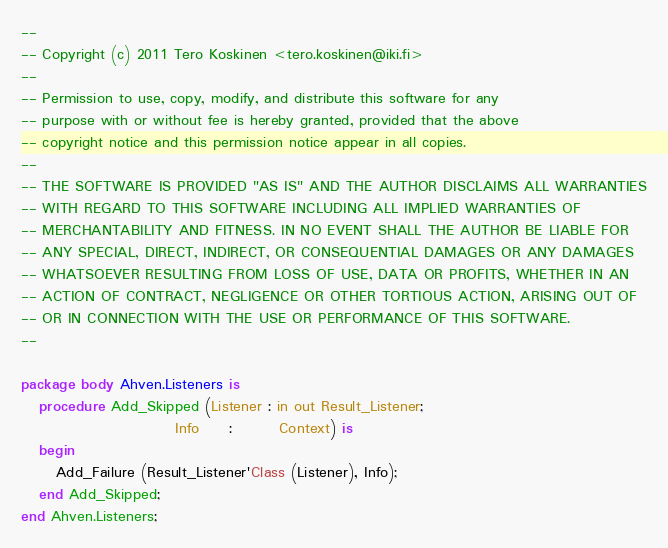Convert code to text. <code><loc_0><loc_0><loc_500><loc_500><_Ada_>--
-- Copyright (c) 2011 Tero Koskinen <tero.koskinen@iki.fi>
--
-- Permission to use, copy, modify, and distribute this software for any
-- purpose with or without fee is hereby granted, provided that the above
-- copyright notice and this permission notice appear in all copies.
--
-- THE SOFTWARE IS PROVIDED "AS IS" AND THE AUTHOR DISCLAIMS ALL WARRANTIES
-- WITH REGARD TO THIS SOFTWARE INCLUDING ALL IMPLIED WARRANTIES OF
-- MERCHANTABILITY AND FITNESS. IN NO EVENT SHALL THE AUTHOR BE LIABLE FOR
-- ANY SPECIAL, DIRECT, INDIRECT, OR CONSEQUENTIAL DAMAGES OR ANY DAMAGES
-- WHATSOEVER RESULTING FROM LOSS OF USE, DATA OR PROFITS, WHETHER IN AN
-- ACTION OF CONTRACT, NEGLIGENCE OR OTHER TORTIOUS ACTION, ARISING OUT OF
-- OR IN CONNECTION WITH THE USE OR PERFORMANCE OF THIS SOFTWARE.
--

package body Ahven.Listeners is
   procedure Add_Skipped (Listener : in out Result_Listener;
                          Info     :        Context) is
   begin
      Add_Failure (Result_Listener'Class (Listener), Info);
   end Add_Skipped;
end Ahven.Listeners;
</code> 